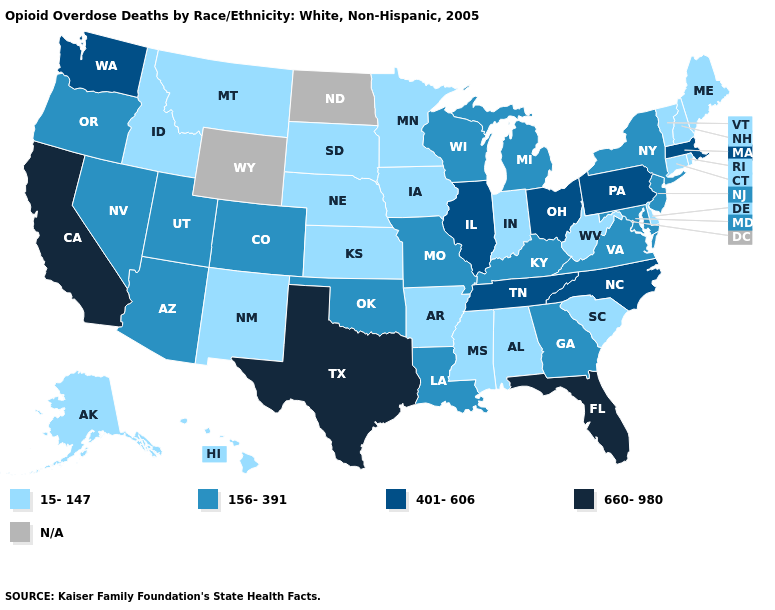Name the states that have a value in the range 156-391?
Quick response, please. Arizona, Colorado, Georgia, Kentucky, Louisiana, Maryland, Michigan, Missouri, Nevada, New Jersey, New York, Oklahoma, Oregon, Utah, Virginia, Wisconsin. Does Maryland have the highest value in the USA?
Answer briefly. No. Name the states that have a value in the range 156-391?
Write a very short answer. Arizona, Colorado, Georgia, Kentucky, Louisiana, Maryland, Michigan, Missouri, Nevada, New Jersey, New York, Oklahoma, Oregon, Utah, Virginia, Wisconsin. What is the value of Nevada?
Concise answer only. 156-391. What is the value of Texas?
Keep it brief. 660-980. Does Delaware have the highest value in the USA?
Quick response, please. No. What is the highest value in the USA?
Be succinct. 660-980. Which states have the highest value in the USA?
Keep it brief. California, Florida, Texas. What is the value of Minnesota?
Short answer required. 15-147. What is the value of Pennsylvania?
Short answer required. 401-606. What is the value of South Dakota?
Keep it brief. 15-147. Name the states that have a value in the range 15-147?
Short answer required. Alabama, Alaska, Arkansas, Connecticut, Delaware, Hawaii, Idaho, Indiana, Iowa, Kansas, Maine, Minnesota, Mississippi, Montana, Nebraska, New Hampshire, New Mexico, Rhode Island, South Carolina, South Dakota, Vermont, West Virginia. What is the highest value in the USA?
Concise answer only. 660-980. Name the states that have a value in the range 660-980?
Concise answer only. California, Florida, Texas. 